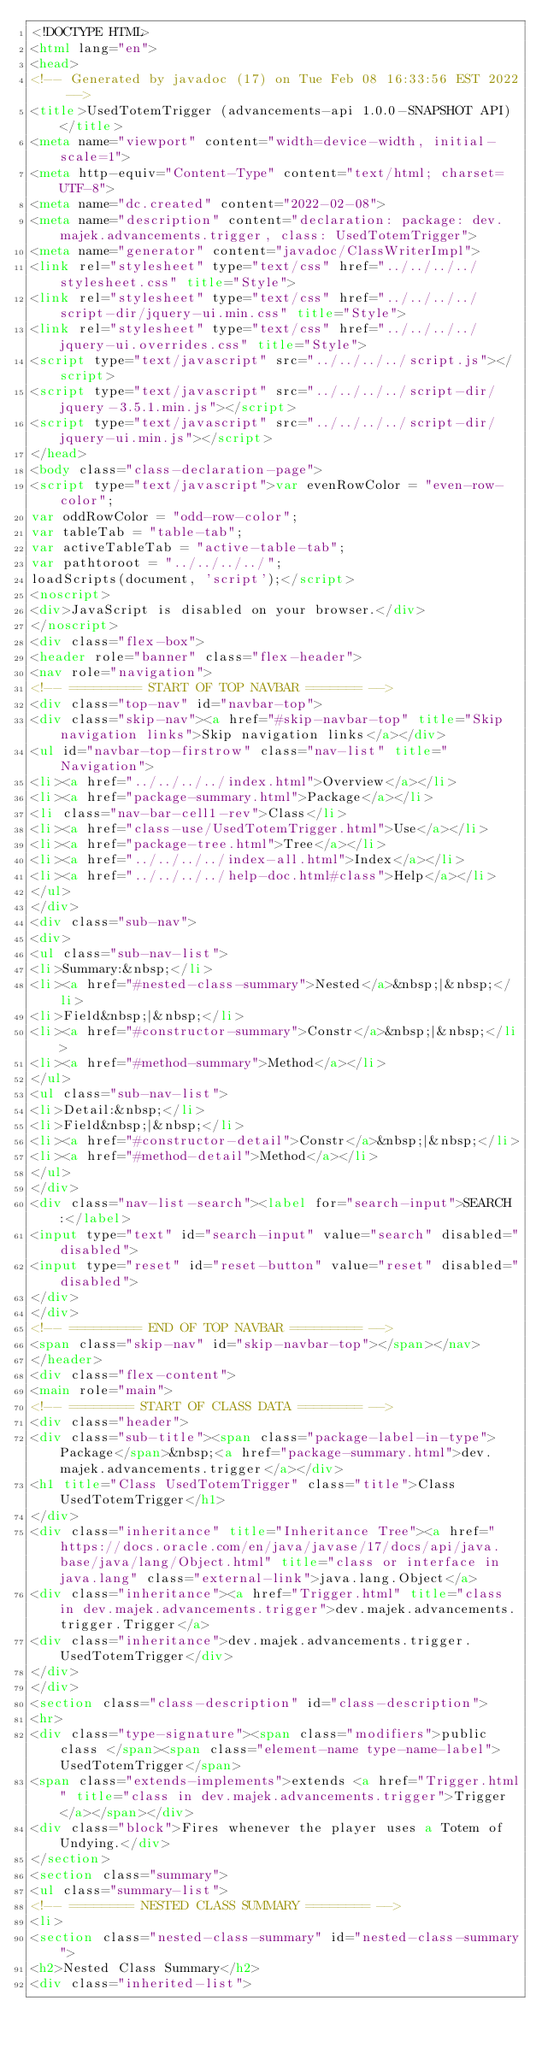Convert code to text. <code><loc_0><loc_0><loc_500><loc_500><_HTML_><!DOCTYPE HTML>
<html lang="en">
<head>
<!-- Generated by javadoc (17) on Tue Feb 08 16:33:56 EST 2022 -->
<title>UsedTotemTrigger (advancements-api 1.0.0-SNAPSHOT API)</title>
<meta name="viewport" content="width=device-width, initial-scale=1">
<meta http-equiv="Content-Type" content="text/html; charset=UTF-8">
<meta name="dc.created" content="2022-02-08">
<meta name="description" content="declaration: package: dev.majek.advancements.trigger, class: UsedTotemTrigger">
<meta name="generator" content="javadoc/ClassWriterImpl">
<link rel="stylesheet" type="text/css" href="../../../../stylesheet.css" title="Style">
<link rel="stylesheet" type="text/css" href="../../../../script-dir/jquery-ui.min.css" title="Style">
<link rel="stylesheet" type="text/css" href="../../../../jquery-ui.overrides.css" title="Style">
<script type="text/javascript" src="../../../../script.js"></script>
<script type="text/javascript" src="../../../../script-dir/jquery-3.5.1.min.js"></script>
<script type="text/javascript" src="../../../../script-dir/jquery-ui.min.js"></script>
</head>
<body class="class-declaration-page">
<script type="text/javascript">var evenRowColor = "even-row-color";
var oddRowColor = "odd-row-color";
var tableTab = "table-tab";
var activeTableTab = "active-table-tab";
var pathtoroot = "../../../../";
loadScripts(document, 'script');</script>
<noscript>
<div>JavaScript is disabled on your browser.</div>
</noscript>
<div class="flex-box">
<header role="banner" class="flex-header">
<nav role="navigation">
<!-- ========= START OF TOP NAVBAR ======= -->
<div class="top-nav" id="navbar-top">
<div class="skip-nav"><a href="#skip-navbar-top" title="Skip navigation links">Skip navigation links</a></div>
<ul id="navbar-top-firstrow" class="nav-list" title="Navigation">
<li><a href="../../../../index.html">Overview</a></li>
<li><a href="package-summary.html">Package</a></li>
<li class="nav-bar-cell1-rev">Class</li>
<li><a href="class-use/UsedTotemTrigger.html">Use</a></li>
<li><a href="package-tree.html">Tree</a></li>
<li><a href="../../../../index-all.html">Index</a></li>
<li><a href="../../../../help-doc.html#class">Help</a></li>
</ul>
</div>
<div class="sub-nav">
<div>
<ul class="sub-nav-list">
<li>Summary:&nbsp;</li>
<li><a href="#nested-class-summary">Nested</a>&nbsp;|&nbsp;</li>
<li>Field&nbsp;|&nbsp;</li>
<li><a href="#constructor-summary">Constr</a>&nbsp;|&nbsp;</li>
<li><a href="#method-summary">Method</a></li>
</ul>
<ul class="sub-nav-list">
<li>Detail:&nbsp;</li>
<li>Field&nbsp;|&nbsp;</li>
<li><a href="#constructor-detail">Constr</a>&nbsp;|&nbsp;</li>
<li><a href="#method-detail">Method</a></li>
</ul>
</div>
<div class="nav-list-search"><label for="search-input">SEARCH:</label>
<input type="text" id="search-input" value="search" disabled="disabled">
<input type="reset" id="reset-button" value="reset" disabled="disabled">
</div>
</div>
<!-- ========= END OF TOP NAVBAR ========= -->
<span class="skip-nav" id="skip-navbar-top"></span></nav>
</header>
<div class="flex-content">
<main role="main">
<!-- ======== START OF CLASS DATA ======== -->
<div class="header">
<div class="sub-title"><span class="package-label-in-type">Package</span>&nbsp;<a href="package-summary.html">dev.majek.advancements.trigger</a></div>
<h1 title="Class UsedTotemTrigger" class="title">Class UsedTotemTrigger</h1>
</div>
<div class="inheritance" title="Inheritance Tree"><a href="https://docs.oracle.com/en/java/javase/17/docs/api/java.base/java/lang/Object.html" title="class or interface in java.lang" class="external-link">java.lang.Object</a>
<div class="inheritance"><a href="Trigger.html" title="class in dev.majek.advancements.trigger">dev.majek.advancements.trigger.Trigger</a>
<div class="inheritance">dev.majek.advancements.trigger.UsedTotemTrigger</div>
</div>
</div>
<section class="class-description" id="class-description">
<hr>
<div class="type-signature"><span class="modifiers">public class </span><span class="element-name type-name-label">UsedTotemTrigger</span>
<span class="extends-implements">extends <a href="Trigger.html" title="class in dev.majek.advancements.trigger">Trigger</a></span></div>
<div class="block">Fires whenever the player uses a Totem of Undying.</div>
</section>
<section class="summary">
<ul class="summary-list">
<!-- ======== NESTED CLASS SUMMARY ======== -->
<li>
<section class="nested-class-summary" id="nested-class-summary">
<h2>Nested Class Summary</h2>
<div class="inherited-list"></code> 